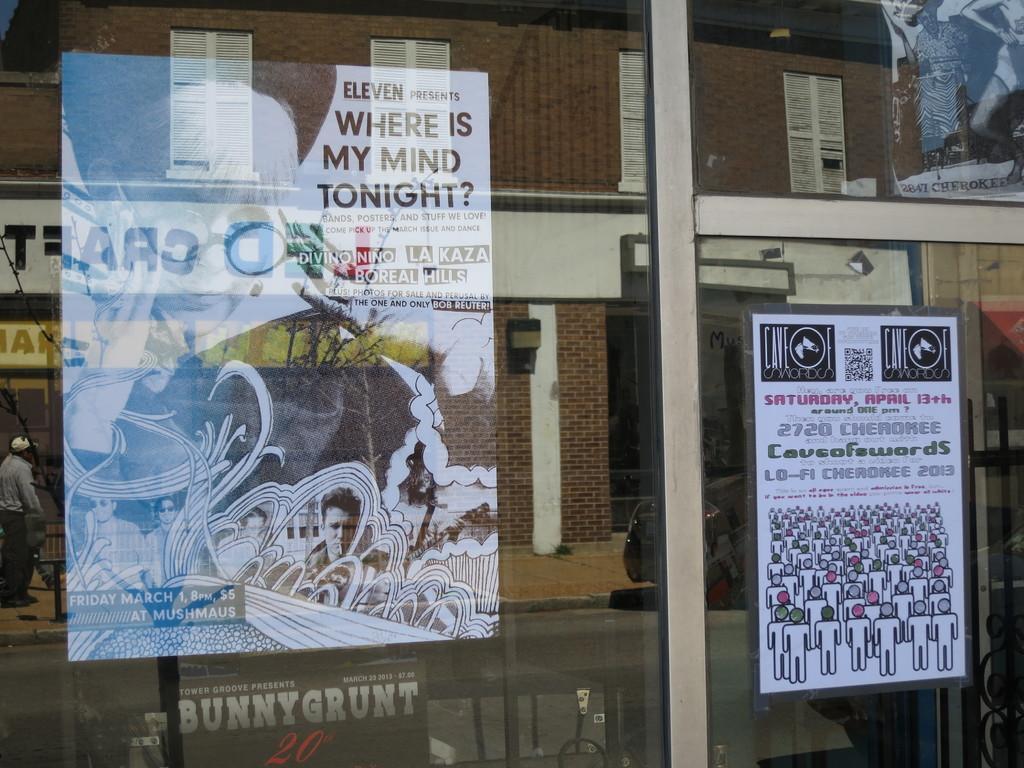Can you describe this image briefly? In this image there is a glass and we can see posts placed on the glass and there are reflections of a building, person, road and a car on the glass. 